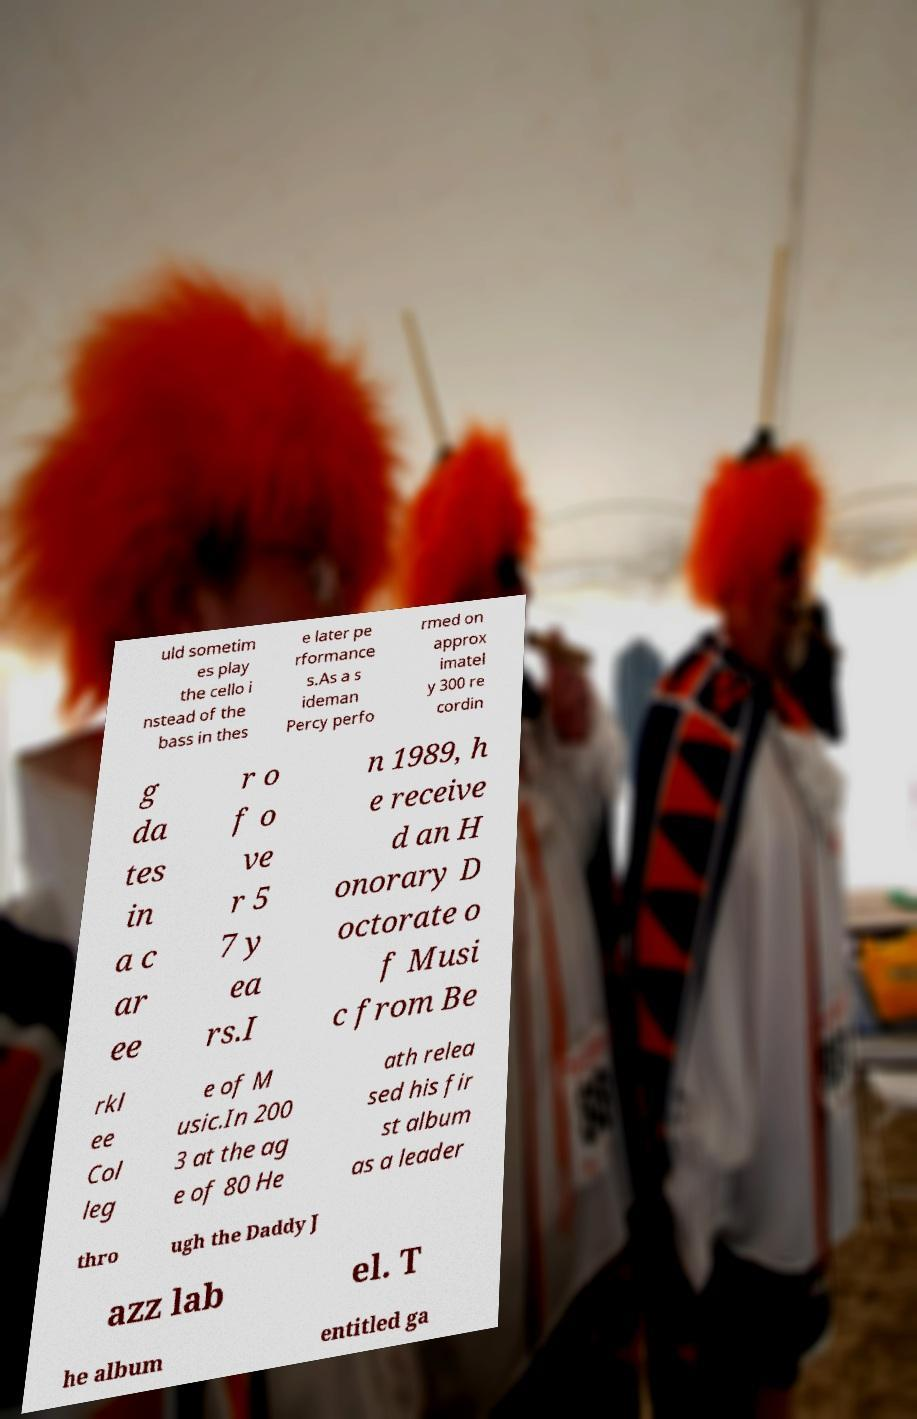What messages or text are displayed in this image? I need them in a readable, typed format. uld sometim es play the cello i nstead of the bass in thes e later pe rformance s.As a s ideman Percy perfo rmed on approx imatel y 300 re cordin g da tes in a c ar ee r o f o ve r 5 7 y ea rs.I n 1989, h e receive d an H onorary D octorate o f Musi c from Be rkl ee Col leg e of M usic.In 200 3 at the ag e of 80 He ath relea sed his fir st album as a leader thro ugh the Daddy J azz lab el. T he album entitled ga 